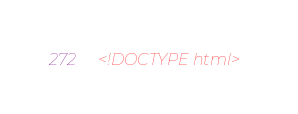<code> <loc_0><loc_0><loc_500><loc_500><_HTML_><!DOCTYPE html></code> 